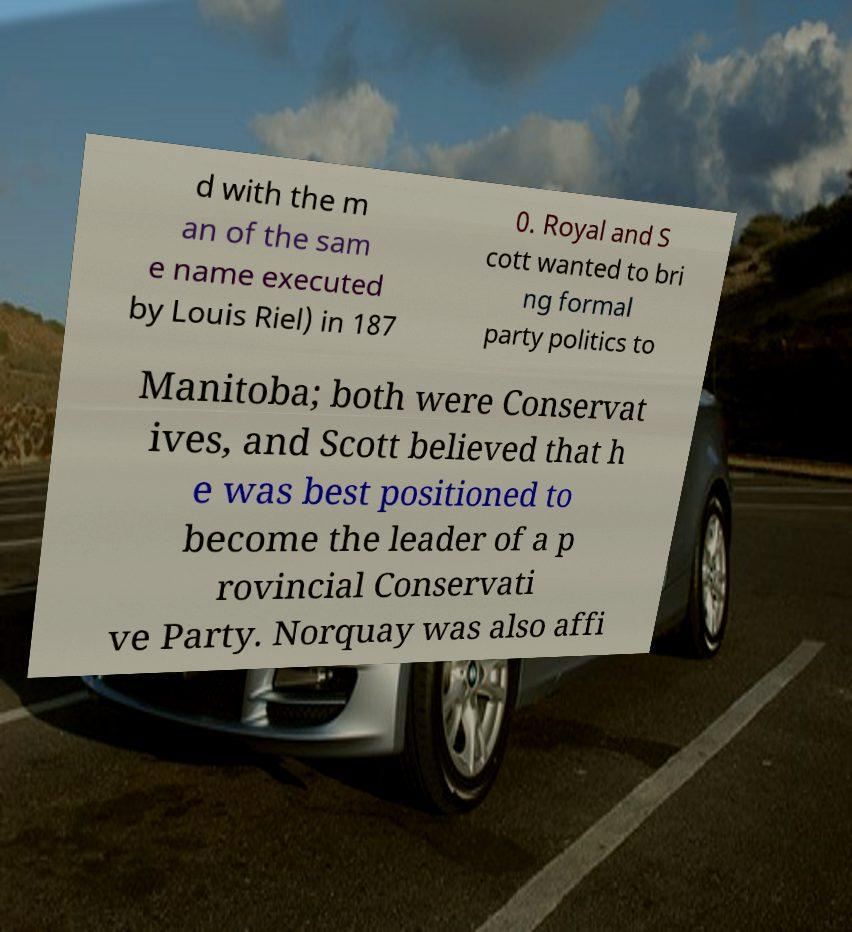For documentation purposes, I need the text within this image transcribed. Could you provide that? d with the m an of the sam e name executed by Louis Riel) in 187 0. Royal and S cott wanted to bri ng formal party politics to Manitoba; both were Conservat ives, and Scott believed that h e was best positioned to become the leader of a p rovincial Conservati ve Party. Norquay was also affi 